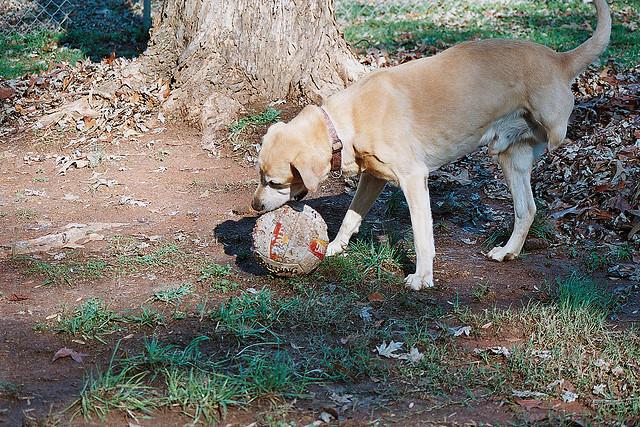What color is the dog?
Quick response, please. Tan. What is the object behind the dog?
Be succinct. Tree. How many dogs in the shot?
Quick response, please. 1. What is the dog chewing?
Give a very brief answer. Ball. 